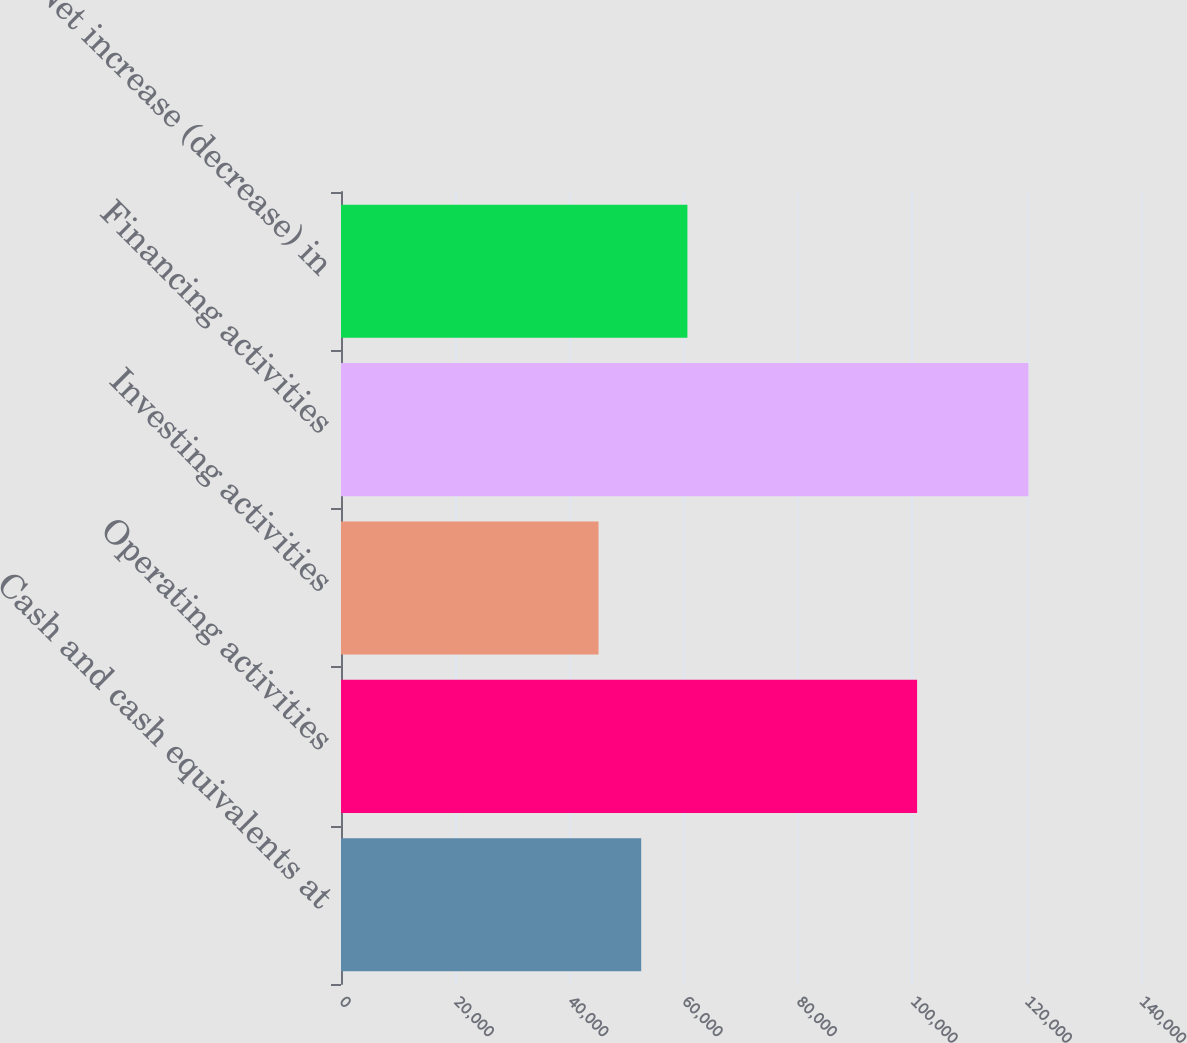<chart> <loc_0><loc_0><loc_500><loc_500><bar_chart><fcel>Cash and cash equivalents at<fcel>Operating activities<fcel>Investing activities<fcel>Financing activities<fcel>Net increase (decrease) in<nl><fcel>52536<fcel>100817<fcel>45065<fcel>120290<fcel>60623<nl></chart> 